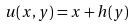Convert formula to latex. <formula><loc_0><loc_0><loc_500><loc_500>u ( x , y ) = x + h ( y )</formula> 